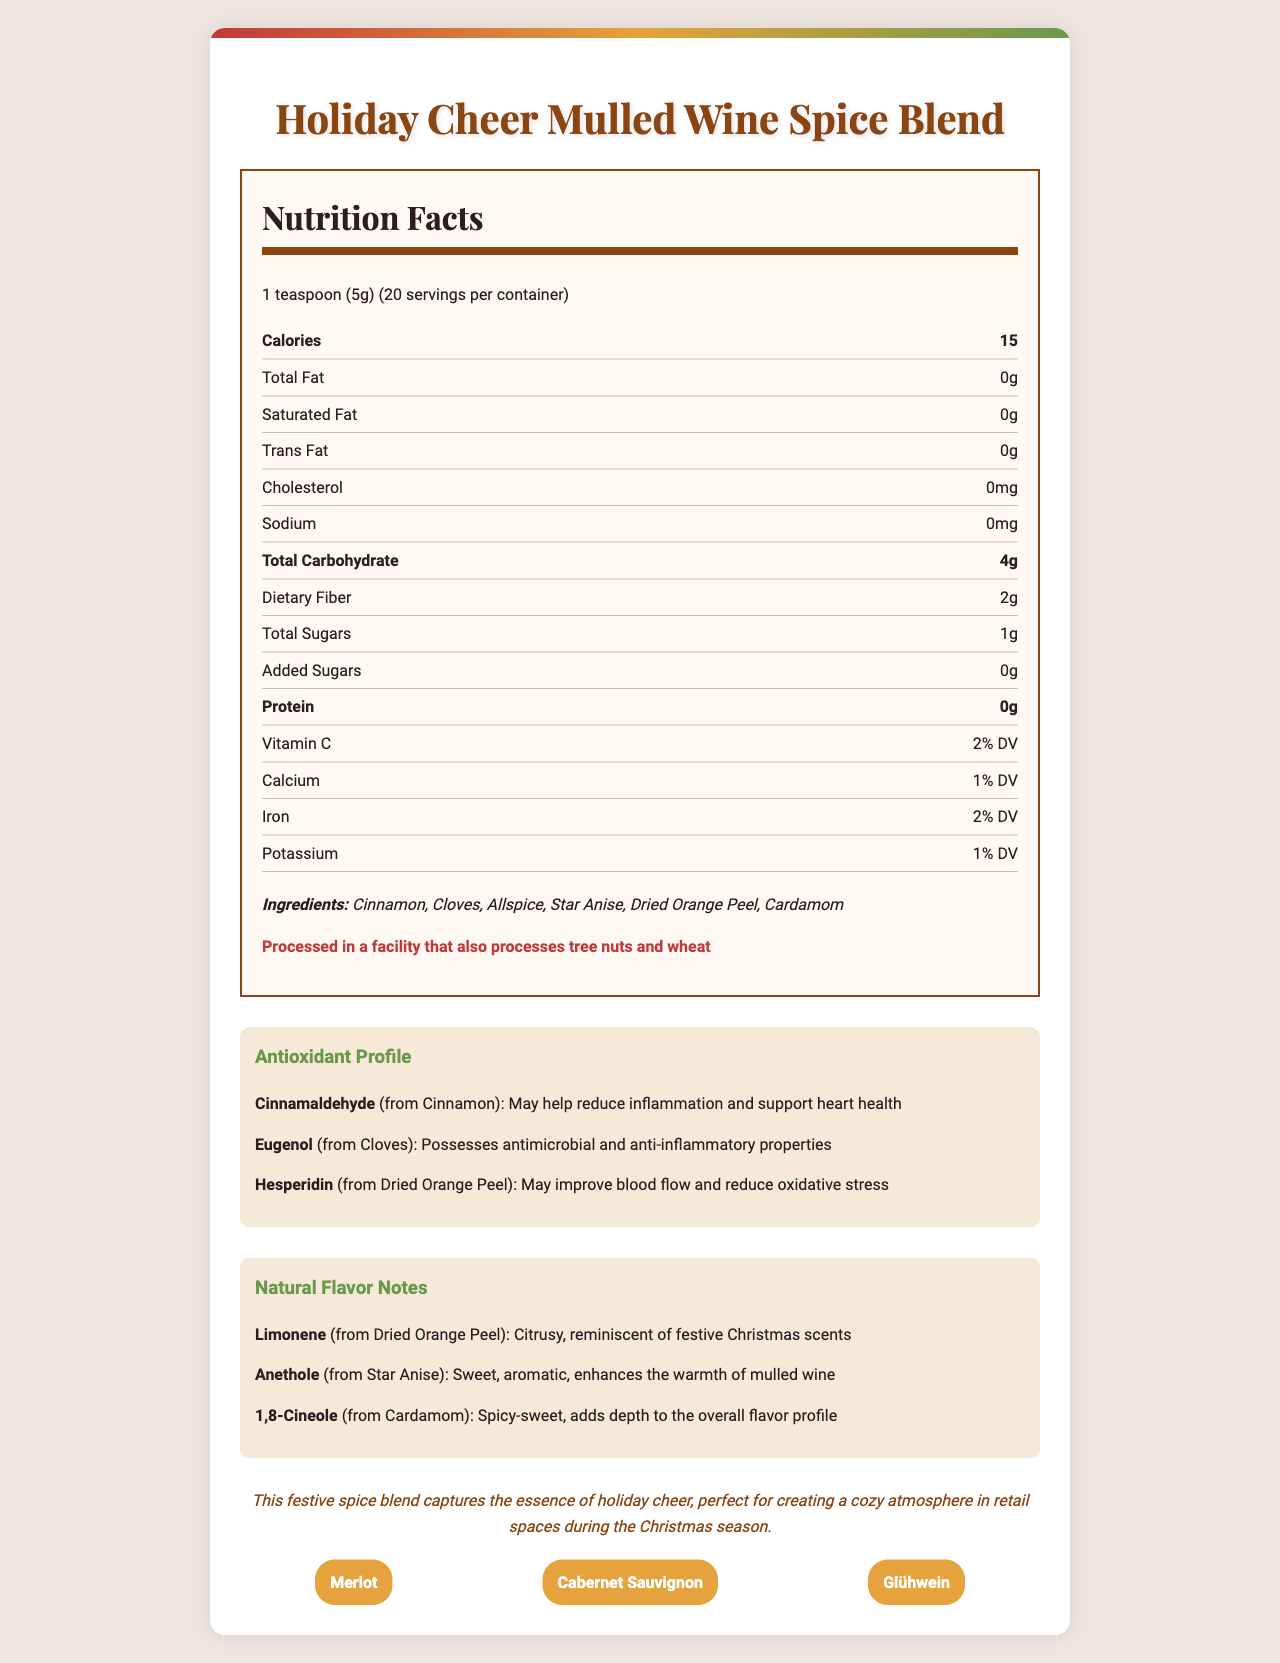what is the serving size of the Holiday Cheer Mulled Wine Spice Blend? The serving size is listed on the nutrition label as 1 teaspoon (5g).
Answer: 1 teaspoon (5g) how many calories are in one serving? The nutrition label indicates that each serving has 15 calories.
Answer: 15 which antioxidant comes from cinnamon and what are its benefits? The antioxidant profile section lists Cinnamaldehyde from cinnamon and its benefits as reducing inflammation and supporting heart health.
Answer: Cinnamaldehyde, May help reduce inflammation and support heart health what percentage of daily value of Vitamin C is provided per serving? The nutrition label shows that Vitamin C makes up 2% of the daily value per serving.
Answer: 2% DV which ingredient in the spice blend provides a citrusy, festive scent? The natural flavors section highlights that Limonene from dried orange peel has a citrusy scent reminiscent of festive Christmas scents.
Answer: Dried Orange Peel how many servings are there per container of the spice blend? A. 10 B. 20 C. 30 The number of servings per container is listed as 20 in the nutrition label.
Answer: B. 20 which flavor note is associated with star anise? A. Citrus B. Sweet and aromatic C. Spicy-sweet The natural flavors section indicates that Anethole from star anise is sweet and aromatic.
Answer: B. Sweet and aromatic does this product contain any added sugars? The nutrition label indicates that there are 0g of added sugars.
Answer: No is this spice blend processed in a facility that handles allergens? The allergen info states that it is processed in a facility that also processes tree nuts and wheat.
Answer: Yes what are the antioxidants and natural flavors present in this spice blend? The antioxidants and natural flavors sections of the document list these components.
Answer: Antioxidants: Cinnamaldehyde (Cinnamon), Eugenol (Cloves), Hesperidin (Dried Orange Peel); Natural Flavors: Limonene (Dried Orange Peel), Anethole (Star Anise), 1,8-Cineole (Cardamom) where should this product be displayed in the store to enhance the seasonal ambiance? The retailer note suggests displaying the product near the wine section to encourage impulse purchases and enhance the seasonal shopping experience.
Answer: Near the wine section summarize the main idea of the document. The document thoroughly describes the product, focusing on its use during the holiday season to enhance customer experience and providing detailed nutritional and ingredient information for informed purchases.
Answer: The document provides comprehensive information about the Holiday Cheer Mulled Wine Spice Blend, detailing its nutritional facts, ingredients, antioxidant profile, natural flavor notes, and seasonal appeal. It emphasizes the product's suitability for creating a festive atmosphere in retail spaces and offers pairing suggestions, storage instructions, and sustainability information. what is the specific role of the cardamom in this spice blend? The natural flavors section describes that 1,8-Cineole from cardamom has a spicy-sweet note and adds depth to the flavor profile.
Answer: Spicy-sweet, adds depth to the overall flavor profile how much dietary fiber does one serving provide? The nutrition label shows that each serving contains 2g of dietary fiber.
Answer: 2g what type of wine is recommended to pair with the spice blend? I. Chardonnay II. Merlot III. Glühwein The pairing suggestions include Merlot and Glühwein.
Answer: II. Merlot, III. Glühwein how should the spice blend be stored to preserve its quality? The storage instructions advise storing the spice blend in a cool, dry place away from direct sunlight to preserve its flavor and aroma.
Answer: In a cool, dry place away from direct sunlight what is the exact mixture of spices in the Holiday Cheer Mulled Wine Spice Blend? The document lists the types of spices used but does not provide the exact mixture amounts.
Answer: Cannot be determined how long is the shelf life of the spice blend once opened? The shelf life is specified as 12 months of opening.
Answer: 12 months 